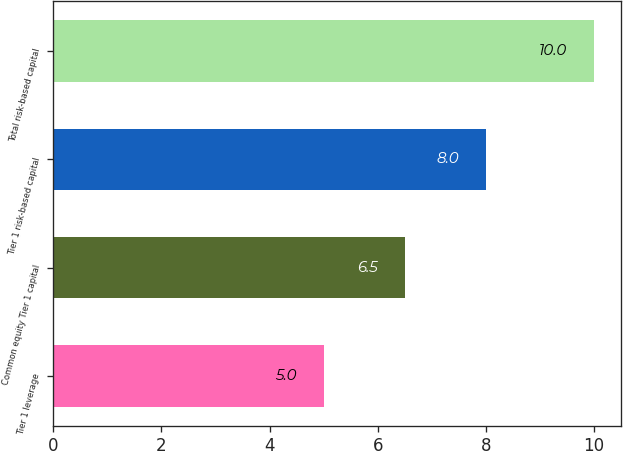Convert chart. <chart><loc_0><loc_0><loc_500><loc_500><bar_chart><fcel>Tier 1 leverage<fcel>Common equity Tier 1 capital<fcel>Tier 1 risk-based capital<fcel>Total risk-based capital<nl><fcel>5<fcel>6.5<fcel>8<fcel>10<nl></chart> 